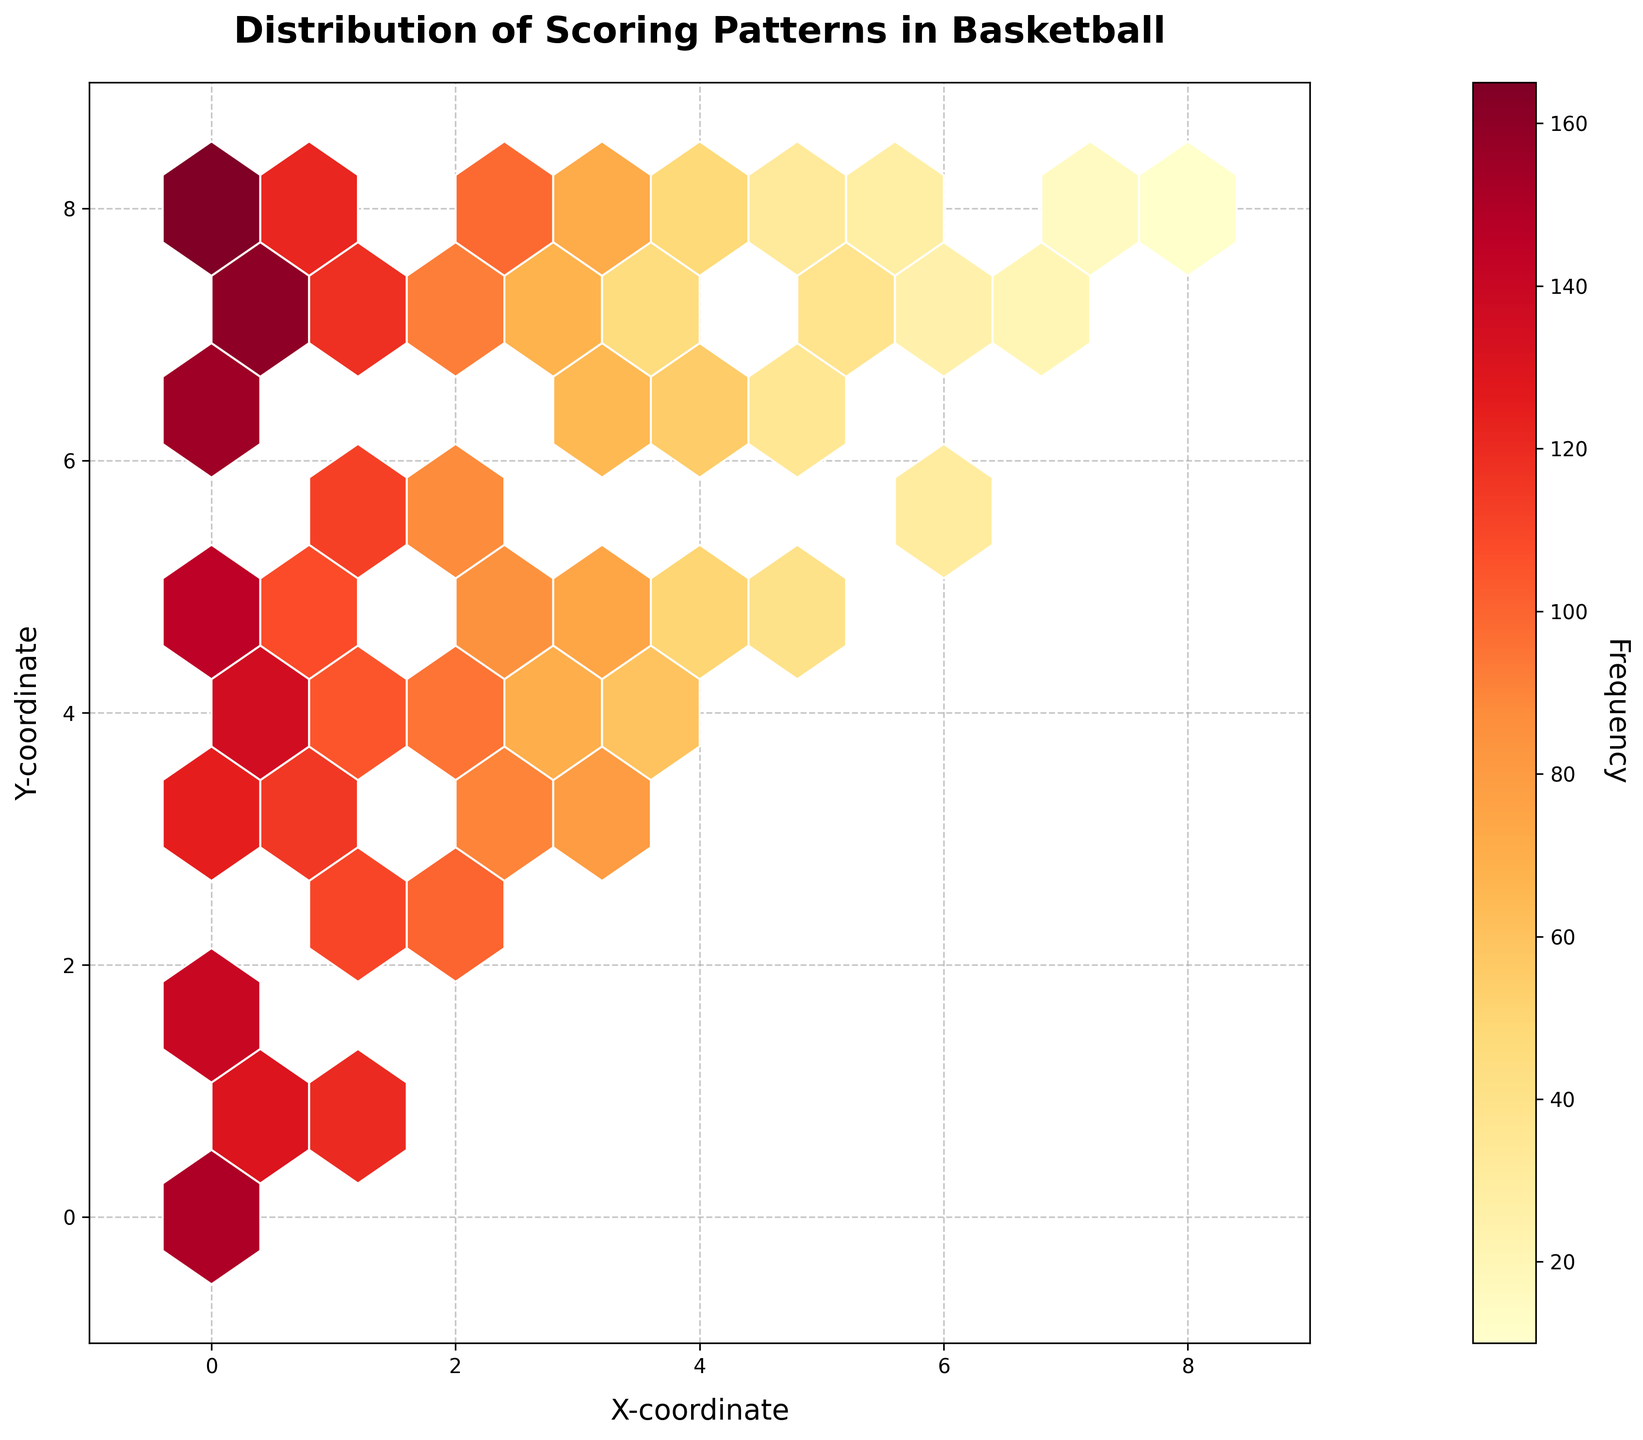What's the title of the plot? The title is usually located at the top center of the figure and it summarizes the main topic or purpose of the plot. Here, the title is "Distribution of Scoring Patterns in Basketball".
Answer: Distribution of Scoring Patterns in Basketball What do the x and y axes represent in this plot? The x and y axes labels are typically located near the axes themselves. In this figure, the x-axis is labeled "X-coordinate" and the y-axis is labeled "Y-coordinate".
Answer: X-coordinate and Y-coordinate What is the color range used in the hexbin plot, and what does it represent? The color range in a hexbin plot shows the varying levels of density or frequency within the bins. Here, the colors range from light yellow to dark red, representing the frequency of scoring patterns. Light yellow indicates lower frequency, and dark red indicates higher frequency.
Answer: Light yellow to dark red for frequency Which region appears to have the highest frequency of scoring? By looking at the color intensity in the plot, the region with the darkest red color indicates the highest frequency. Here, it is around the coordinate (0, 8).
Answer: Around the coordinate (0, 8) How do shot frequencies change as you move diagonally from (0,0) to (8,8)? Assess the color change along the diagonal path from (0,0) to (8,8). The color starts as dark red and gradually lightens, indicating a decrease in frequency as you move away from (0,0).
Answer: Frequency decreases Are there any regions with no shot frequencies recorded? Identify if there are any white or uncolored regions within the plot, which would indicate no frequencies recorded. Based on the x and y limits, it appears that there are no white spaces, implying all regions have some frequency recorded.
Answer: No Which bin has a higher frequency, (0,0) or (3,3)? Compare the color intensity of the bins at (0,0) and (3,3). The bin at (0,0) is darker red, indicating a higher frequency compared to the lighter orange bin at (3,3).
Answer: (0,0) How does the frequency at (1,1) compare to (3,5)? Observe and compare the color intensities at (1,1) and (3,5). The color at (1,1) is darker than at (3,5), indicating a higher frequency at (1,1).
Answer: (1,1) has a higher frequency Which areas have the least frequency of scoring? Identify the areas with the lightest colors (near light yellow) within the plot indicating the least scoring frequency, which is observed near the coordinates (7,8) and (8,8).
Answer: Near (7,8) and (8,8) What is the significance of the color bar on the right side of the plot? The color bar provides a reference for the color intensity used in the hexbin plot, indicating the range of frequencies. The lower end of the color bar corresponds to light yellow (low frequency), while the upper end corresponds to dark red (high frequency).
Answer: It indicates the frequency range What is the effect of shot location on shot frequency distribution? By observing the distribution of colors, we can infer that certain locations, such as close range around (0,0) and specific high-frequency areas, are more preferable for shots compared to others, which implies a pattern in shot selection in basketball.
Answer: Certain locations have higher frequencies 